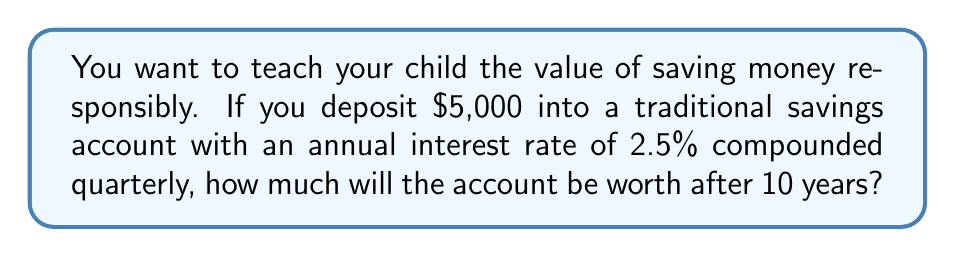Solve this math problem. To solve this problem, we'll use the compound interest formula:

$$A = P(1 + \frac{r}{n})^{nt}$$

Where:
$A$ = final amount
$P$ = principal (initial investment)
$r$ = annual interest rate (as a decimal)
$n$ = number of times interest is compounded per year
$t$ = number of years

Given:
$P = \$5,000$
$r = 2.5\% = 0.025$
$n = 4$ (compounded quarterly)
$t = 10$ years

Let's substitute these values into the formula:

$$A = 5000(1 + \frac{0.025}{4})^{4 \cdot 10}$$

$$A = 5000(1 + 0.00625)^{40}$$

$$A = 5000(1.00625)^{40}$$

Using a calculator or computer:

$$A = 5000 \cdot 1.2824303$$

$$A = 6412.15$$
Answer: $6,412.15 